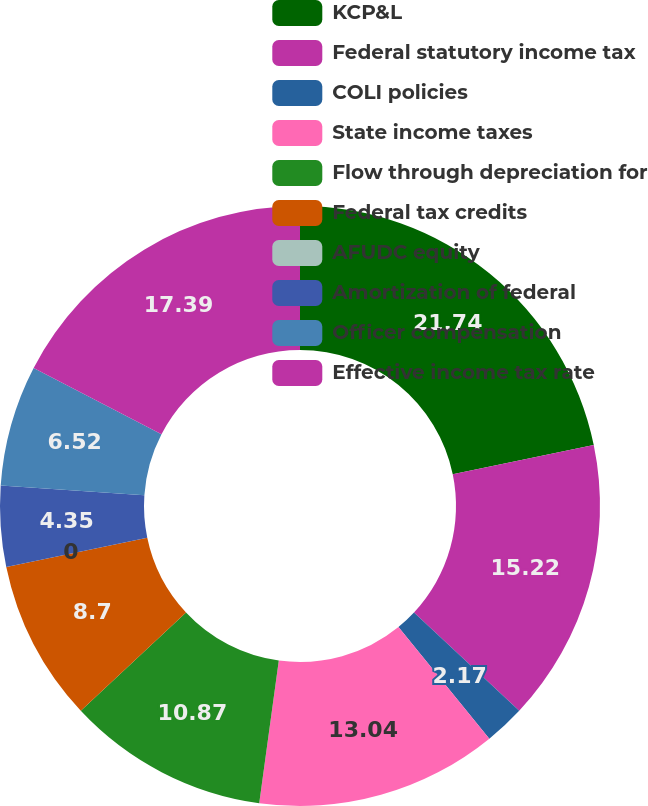<chart> <loc_0><loc_0><loc_500><loc_500><pie_chart><fcel>KCP&L<fcel>Federal statutory income tax<fcel>COLI policies<fcel>State income taxes<fcel>Flow through depreciation for<fcel>Federal tax credits<fcel>AFUDC equity<fcel>Amortization of federal<fcel>Officer compensation<fcel>Effective income tax rate<nl><fcel>21.74%<fcel>15.22%<fcel>2.17%<fcel>13.04%<fcel>10.87%<fcel>8.7%<fcel>0.0%<fcel>4.35%<fcel>6.52%<fcel>17.39%<nl></chart> 